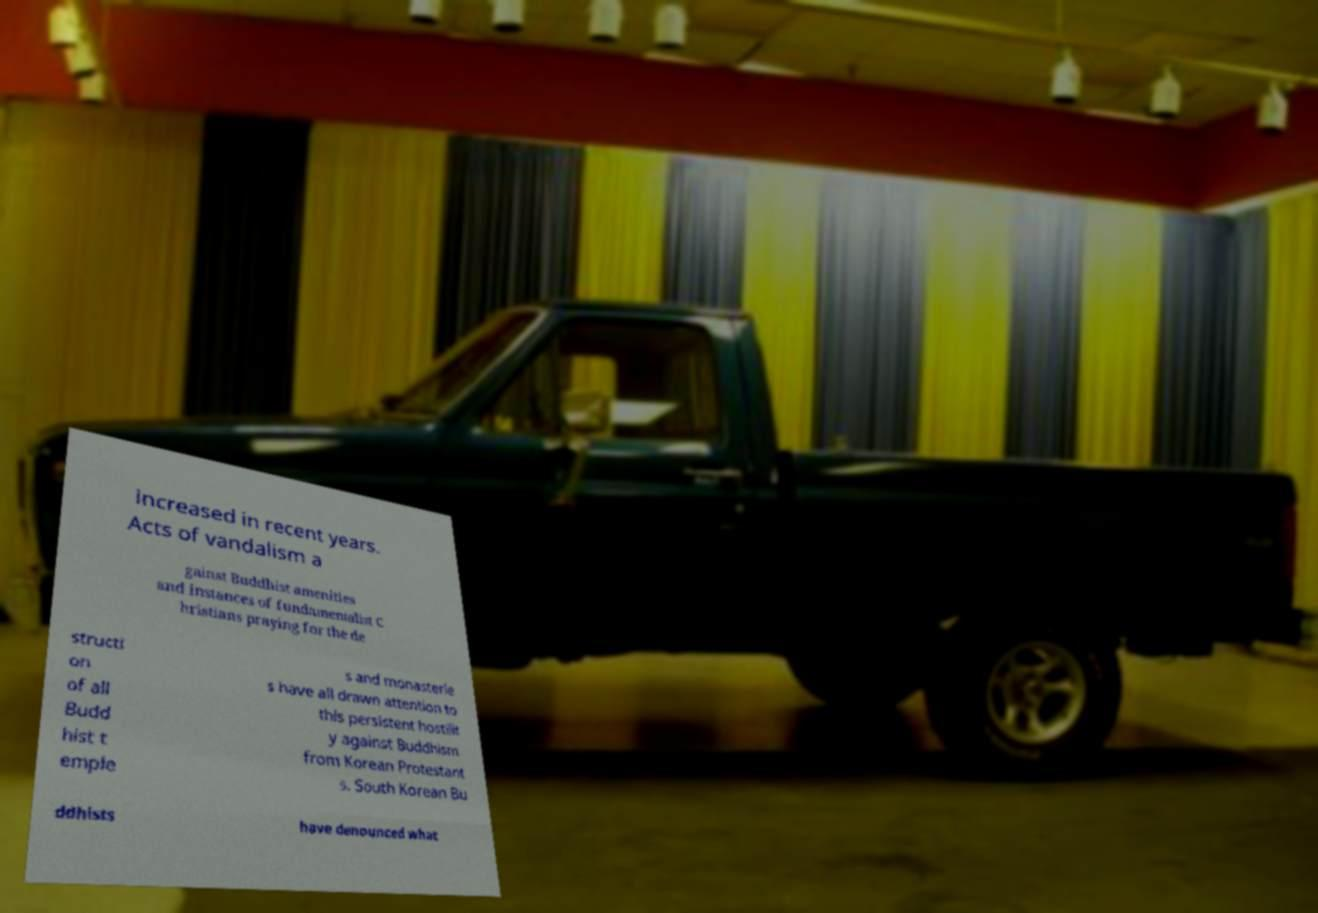There's text embedded in this image that I need extracted. Can you transcribe it verbatim? increased in recent years. Acts of vandalism a gainst Buddhist amenities and instances of fundamentalist C hristians praying for the de structi on of all Budd hist t emple s and monasterie s have all drawn attention to this persistent hostilit y against Buddhism from Korean Protestant s. South Korean Bu ddhists have denounced what 